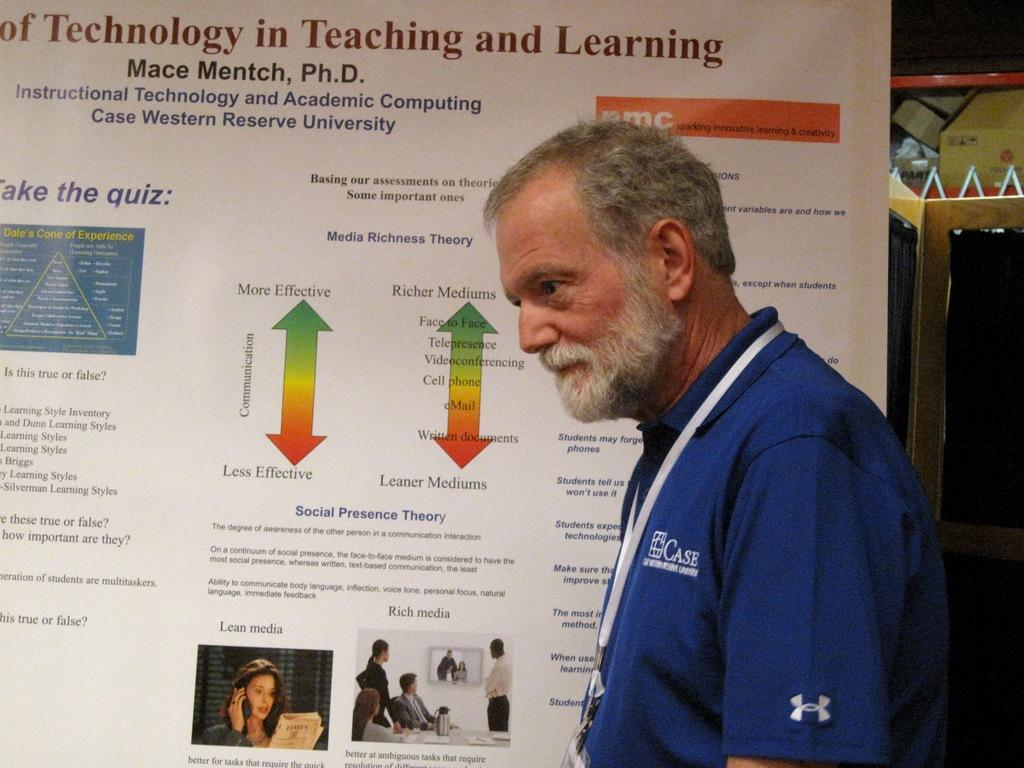<image>
Provide a brief description of the given image. A gray haired man with beard standing next to an informational bulletin board dealing with Teaching and Learning technology. 